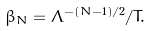Convert formula to latex. <formula><loc_0><loc_0><loc_500><loc_500>\beta _ { N } = \Lambda ^ { - ( N - 1 ) / 2 } / T .</formula> 